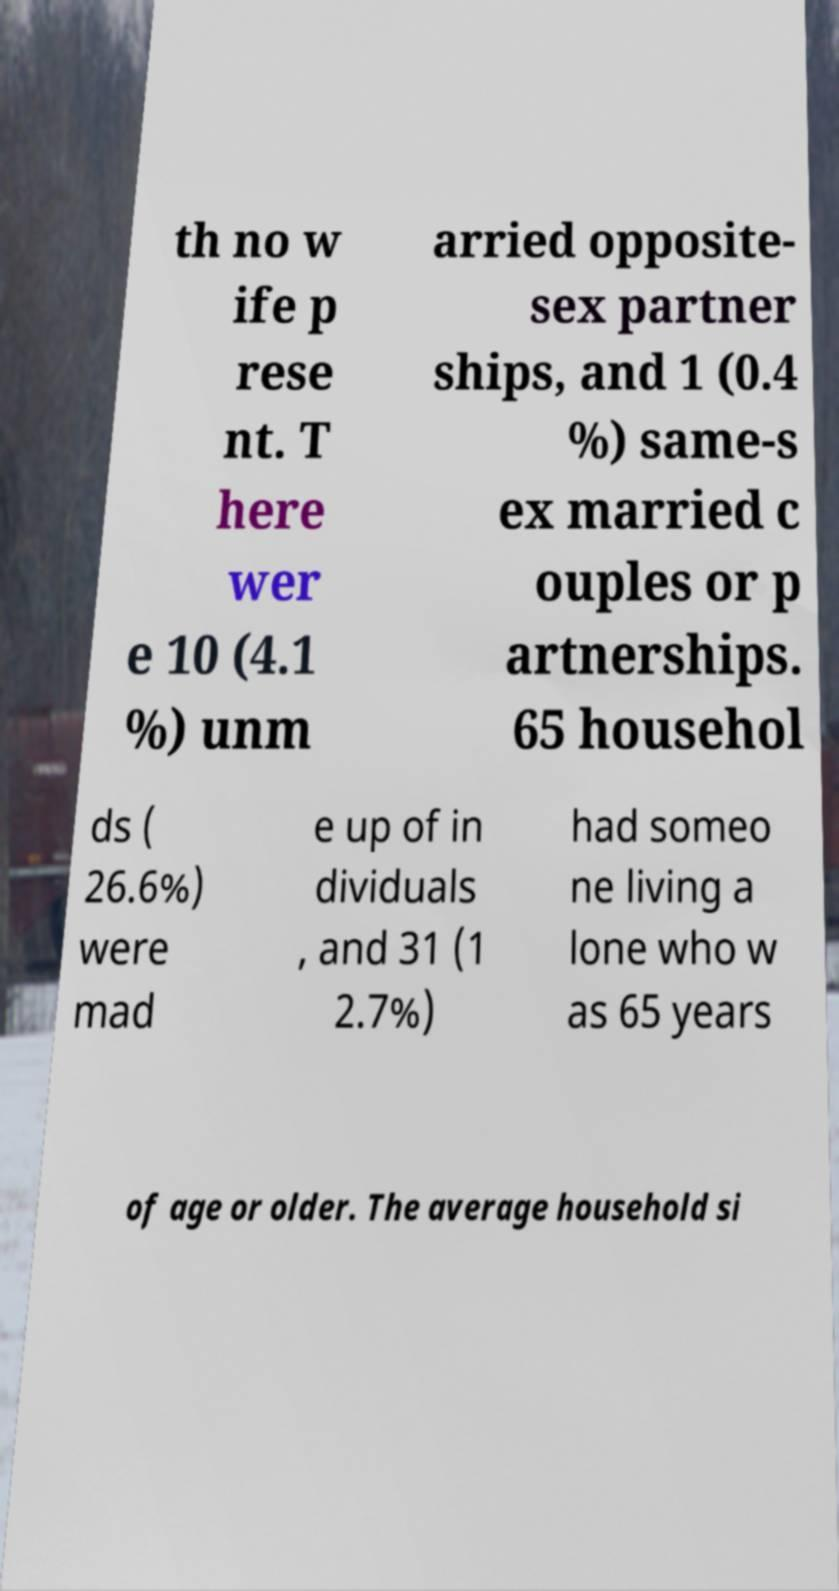Can you accurately transcribe the text from the provided image for me? th no w ife p rese nt. T here wer e 10 (4.1 %) unm arried opposite- sex partner ships, and 1 (0.4 %) same-s ex married c ouples or p artnerships. 65 househol ds ( 26.6%) were mad e up of in dividuals , and 31 (1 2.7%) had someo ne living a lone who w as 65 years of age or older. The average household si 